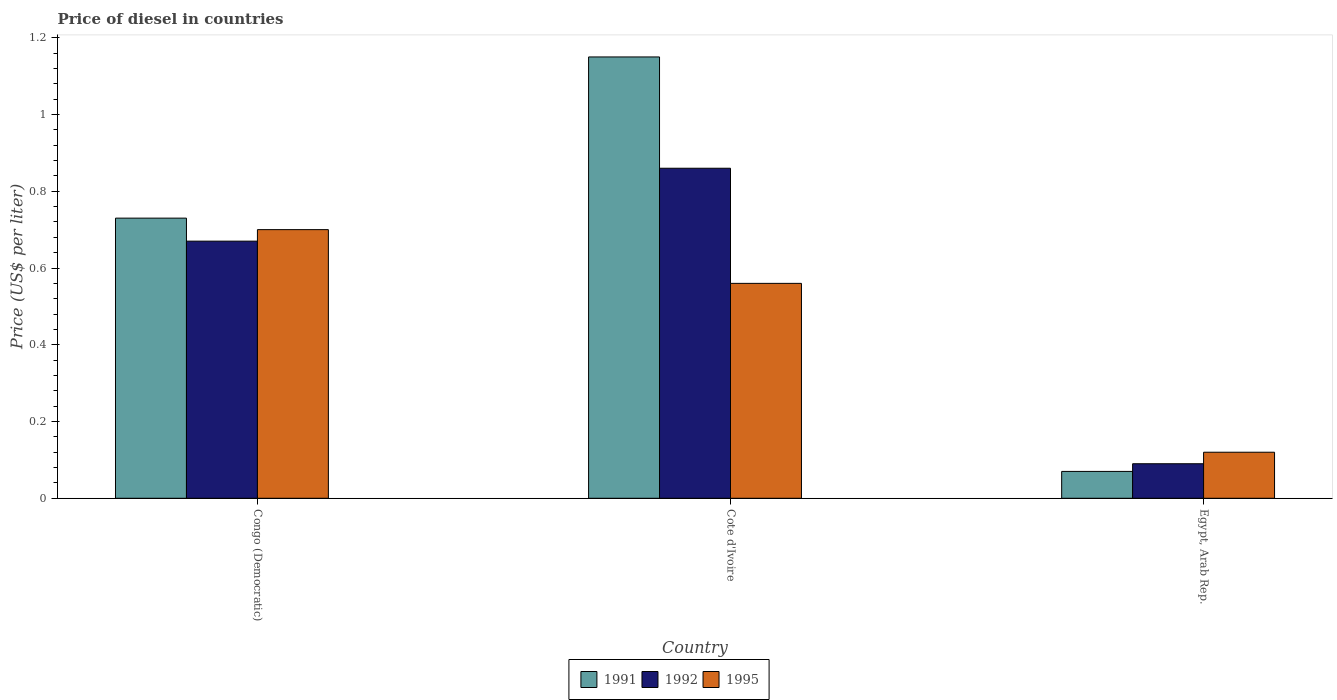How many different coloured bars are there?
Provide a short and direct response. 3. How many groups of bars are there?
Ensure brevity in your answer.  3. Are the number of bars per tick equal to the number of legend labels?
Give a very brief answer. Yes. How many bars are there on the 1st tick from the left?
Provide a short and direct response. 3. What is the label of the 3rd group of bars from the left?
Offer a terse response. Egypt, Arab Rep. What is the price of diesel in 1995 in Egypt, Arab Rep.?
Keep it short and to the point. 0.12. Across all countries, what is the maximum price of diesel in 1995?
Your response must be concise. 0.7. Across all countries, what is the minimum price of diesel in 1995?
Your response must be concise. 0.12. In which country was the price of diesel in 1992 maximum?
Your answer should be compact. Cote d'Ivoire. In which country was the price of diesel in 1992 minimum?
Your answer should be compact. Egypt, Arab Rep. What is the total price of diesel in 1991 in the graph?
Ensure brevity in your answer.  1.95. What is the difference between the price of diesel in 1992 in Congo (Democratic) and that in Egypt, Arab Rep.?
Offer a very short reply. 0.58. What is the difference between the price of diesel in 1991 in Egypt, Arab Rep. and the price of diesel in 1995 in Congo (Democratic)?
Ensure brevity in your answer.  -0.63. What is the average price of diesel in 1995 per country?
Keep it short and to the point. 0.46. What is the difference between the price of diesel of/in 1995 and price of diesel of/in 1992 in Cote d'Ivoire?
Offer a terse response. -0.3. What is the ratio of the price of diesel in 1991 in Cote d'Ivoire to that in Egypt, Arab Rep.?
Ensure brevity in your answer.  16.43. What is the difference between the highest and the second highest price of diesel in 1992?
Ensure brevity in your answer.  0.19. What is the difference between the highest and the lowest price of diesel in 1992?
Offer a very short reply. 0.77. What does the 3rd bar from the left in Cote d'Ivoire represents?
Ensure brevity in your answer.  1995. What does the 2nd bar from the right in Cote d'Ivoire represents?
Ensure brevity in your answer.  1992. Are all the bars in the graph horizontal?
Your response must be concise. No. How many countries are there in the graph?
Make the answer very short. 3. What is the difference between two consecutive major ticks on the Y-axis?
Ensure brevity in your answer.  0.2. Are the values on the major ticks of Y-axis written in scientific E-notation?
Ensure brevity in your answer.  No. Does the graph contain grids?
Offer a terse response. No. How many legend labels are there?
Provide a succinct answer. 3. How are the legend labels stacked?
Offer a terse response. Horizontal. What is the title of the graph?
Ensure brevity in your answer.  Price of diesel in countries. Does "1998" appear as one of the legend labels in the graph?
Provide a short and direct response. No. What is the label or title of the Y-axis?
Offer a very short reply. Price (US$ per liter). What is the Price (US$ per liter) in 1991 in Congo (Democratic)?
Offer a terse response. 0.73. What is the Price (US$ per liter) of 1992 in Congo (Democratic)?
Your response must be concise. 0.67. What is the Price (US$ per liter) in 1995 in Congo (Democratic)?
Keep it short and to the point. 0.7. What is the Price (US$ per liter) in 1991 in Cote d'Ivoire?
Ensure brevity in your answer.  1.15. What is the Price (US$ per liter) in 1992 in Cote d'Ivoire?
Make the answer very short. 0.86. What is the Price (US$ per liter) of 1995 in Cote d'Ivoire?
Offer a very short reply. 0.56. What is the Price (US$ per liter) in 1991 in Egypt, Arab Rep.?
Your response must be concise. 0.07. What is the Price (US$ per liter) of 1992 in Egypt, Arab Rep.?
Make the answer very short. 0.09. What is the Price (US$ per liter) of 1995 in Egypt, Arab Rep.?
Your answer should be compact. 0.12. Across all countries, what is the maximum Price (US$ per liter) in 1991?
Provide a succinct answer. 1.15. Across all countries, what is the maximum Price (US$ per liter) in 1992?
Ensure brevity in your answer.  0.86. Across all countries, what is the maximum Price (US$ per liter) in 1995?
Make the answer very short. 0.7. Across all countries, what is the minimum Price (US$ per liter) of 1991?
Ensure brevity in your answer.  0.07. Across all countries, what is the minimum Price (US$ per liter) in 1992?
Your answer should be very brief. 0.09. Across all countries, what is the minimum Price (US$ per liter) in 1995?
Your response must be concise. 0.12. What is the total Price (US$ per liter) in 1991 in the graph?
Your answer should be compact. 1.95. What is the total Price (US$ per liter) in 1992 in the graph?
Your response must be concise. 1.62. What is the total Price (US$ per liter) of 1995 in the graph?
Give a very brief answer. 1.38. What is the difference between the Price (US$ per liter) in 1991 in Congo (Democratic) and that in Cote d'Ivoire?
Provide a succinct answer. -0.42. What is the difference between the Price (US$ per liter) of 1992 in Congo (Democratic) and that in Cote d'Ivoire?
Your answer should be very brief. -0.19. What is the difference between the Price (US$ per liter) in 1995 in Congo (Democratic) and that in Cote d'Ivoire?
Provide a short and direct response. 0.14. What is the difference between the Price (US$ per liter) of 1991 in Congo (Democratic) and that in Egypt, Arab Rep.?
Your response must be concise. 0.66. What is the difference between the Price (US$ per liter) in 1992 in Congo (Democratic) and that in Egypt, Arab Rep.?
Offer a terse response. 0.58. What is the difference between the Price (US$ per liter) of 1995 in Congo (Democratic) and that in Egypt, Arab Rep.?
Provide a short and direct response. 0.58. What is the difference between the Price (US$ per liter) in 1991 in Cote d'Ivoire and that in Egypt, Arab Rep.?
Offer a very short reply. 1.08. What is the difference between the Price (US$ per liter) of 1992 in Cote d'Ivoire and that in Egypt, Arab Rep.?
Offer a terse response. 0.77. What is the difference between the Price (US$ per liter) of 1995 in Cote d'Ivoire and that in Egypt, Arab Rep.?
Give a very brief answer. 0.44. What is the difference between the Price (US$ per liter) of 1991 in Congo (Democratic) and the Price (US$ per liter) of 1992 in Cote d'Ivoire?
Give a very brief answer. -0.13. What is the difference between the Price (US$ per liter) in 1991 in Congo (Democratic) and the Price (US$ per liter) in 1995 in Cote d'Ivoire?
Offer a very short reply. 0.17. What is the difference between the Price (US$ per liter) of 1992 in Congo (Democratic) and the Price (US$ per liter) of 1995 in Cote d'Ivoire?
Offer a terse response. 0.11. What is the difference between the Price (US$ per liter) in 1991 in Congo (Democratic) and the Price (US$ per liter) in 1992 in Egypt, Arab Rep.?
Ensure brevity in your answer.  0.64. What is the difference between the Price (US$ per liter) of 1991 in Congo (Democratic) and the Price (US$ per liter) of 1995 in Egypt, Arab Rep.?
Give a very brief answer. 0.61. What is the difference between the Price (US$ per liter) of 1992 in Congo (Democratic) and the Price (US$ per liter) of 1995 in Egypt, Arab Rep.?
Provide a succinct answer. 0.55. What is the difference between the Price (US$ per liter) in 1991 in Cote d'Ivoire and the Price (US$ per liter) in 1992 in Egypt, Arab Rep.?
Offer a terse response. 1.06. What is the difference between the Price (US$ per liter) of 1991 in Cote d'Ivoire and the Price (US$ per liter) of 1995 in Egypt, Arab Rep.?
Ensure brevity in your answer.  1.03. What is the difference between the Price (US$ per liter) of 1992 in Cote d'Ivoire and the Price (US$ per liter) of 1995 in Egypt, Arab Rep.?
Provide a succinct answer. 0.74. What is the average Price (US$ per liter) of 1991 per country?
Provide a succinct answer. 0.65. What is the average Price (US$ per liter) of 1992 per country?
Give a very brief answer. 0.54. What is the average Price (US$ per liter) in 1995 per country?
Offer a very short reply. 0.46. What is the difference between the Price (US$ per liter) of 1991 and Price (US$ per liter) of 1992 in Congo (Democratic)?
Keep it short and to the point. 0.06. What is the difference between the Price (US$ per liter) in 1992 and Price (US$ per liter) in 1995 in Congo (Democratic)?
Provide a short and direct response. -0.03. What is the difference between the Price (US$ per liter) of 1991 and Price (US$ per liter) of 1992 in Cote d'Ivoire?
Give a very brief answer. 0.29. What is the difference between the Price (US$ per liter) of 1991 and Price (US$ per liter) of 1995 in Cote d'Ivoire?
Give a very brief answer. 0.59. What is the difference between the Price (US$ per liter) in 1992 and Price (US$ per liter) in 1995 in Cote d'Ivoire?
Make the answer very short. 0.3. What is the difference between the Price (US$ per liter) of 1991 and Price (US$ per liter) of 1992 in Egypt, Arab Rep.?
Offer a terse response. -0.02. What is the difference between the Price (US$ per liter) of 1991 and Price (US$ per liter) of 1995 in Egypt, Arab Rep.?
Provide a short and direct response. -0.05. What is the difference between the Price (US$ per liter) of 1992 and Price (US$ per liter) of 1995 in Egypt, Arab Rep.?
Provide a short and direct response. -0.03. What is the ratio of the Price (US$ per liter) of 1991 in Congo (Democratic) to that in Cote d'Ivoire?
Provide a succinct answer. 0.63. What is the ratio of the Price (US$ per liter) in 1992 in Congo (Democratic) to that in Cote d'Ivoire?
Keep it short and to the point. 0.78. What is the ratio of the Price (US$ per liter) in 1991 in Congo (Democratic) to that in Egypt, Arab Rep.?
Offer a terse response. 10.43. What is the ratio of the Price (US$ per liter) of 1992 in Congo (Democratic) to that in Egypt, Arab Rep.?
Provide a short and direct response. 7.44. What is the ratio of the Price (US$ per liter) in 1995 in Congo (Democratic) to that in Egypt, Arab Rep.?
Provide a succinct answer. 5.83. What is the ratio of the Price (US$ per liter) in 1991 in Cote d'Ivoire to that in Egypt, Arab Rep.?
Keep it short and to the point. 16.43. What is the ratio of the Price (US$ per liter) of 1992 in Cote d'Ivoire to that in Egypt, Arab Rep.?
Provide a short and direct response. 9.56. What is the ratio of the Price (US$ per liter) in 1995 in Cote d'Ivoire to that in Egypt, Arab Rep.?
Provide a succinct answer. 4.67. What is the difference between the highest and the second highest Price (US$ per liter) of 1991?
Make the answer very short. 0.42. What is the difference between the highest and the second highest Price (US$ per liter) in 1992?
Make the answer very short. 0.19. What is the difference between the highest and the second highest Price (US$ per liter) of 1995?
Make the answer very short. 0.14. What is the difference between the highest and the lowest Price (US$ per liter) of 1992?
Provide a short and direct response. 0.77. What is the difference between the highest and the lowest Price (US$ per liter) of 1995?
Provide a short and direct response. 0.58. 